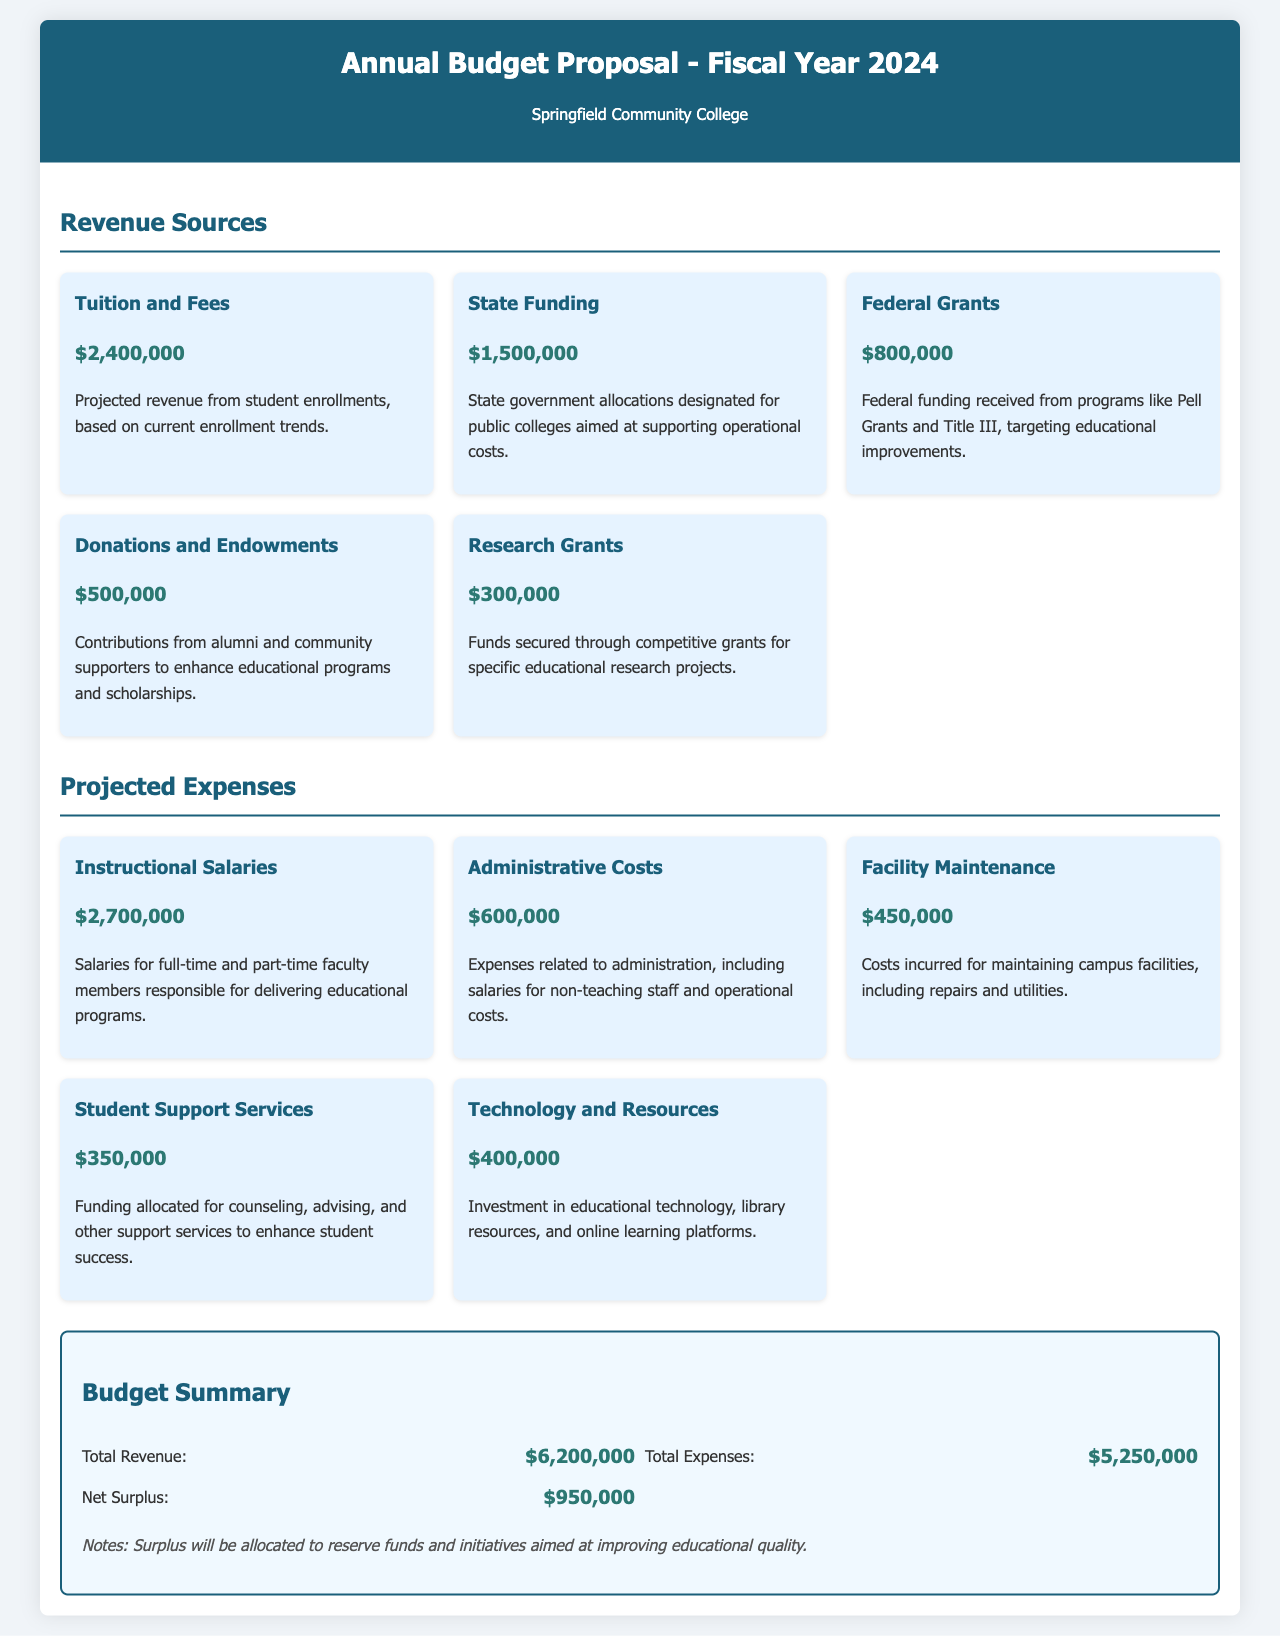What is the total revenue? The total revenue is calculated by summing all the projected revenue sources listed in the document, which equals $2,400,000 + $1,500,000 + $800,000 + $500,000 + $300,000 = $6,200,000.
Answer: $6,200,000 What is the amount for federal grants? The document specifies that the projected revenue from federal grants is stated separately, which is $800,000.
Answer: $800,000 How much is allocated for instructional salaries? The total amount dedicated to instructional salaries is explicitly mentioned as $2,700,000 in the projected expenses section.
Answer: $2,700,000 What is the net surplus? The net surplus is derived from subtracting the total expenses from the total revenue, resulting in $6,200,000 - $5,250,000 = $950,000.
Answer: $950,000 What is the total amount projected for student support services? The document clearly states that the projected expenses for student support services amount to $350,000.
Answer: $350,000 Which revenue source has the highest allocation? The highest allocation among the revenue sources is tuition and fees, with an amount of $2,400,000.
Answer: Tuition and Fees What is the budget summary's description of the surplus allocation? The notes in the budget summary mention that the surplus will be allocated to reserve funds and initiatives aimed at improving educational quality.
Answer: Reserve funds and initiatives What are the total administrative costs? The document details that the administrative costs are projected at $600,000.
Answer: $600,000 How much is allocated for technology and resources? Within the projected expenses depicted in the document, the funding for technology and resources is specified as $400,000.
Answer: $400,000 